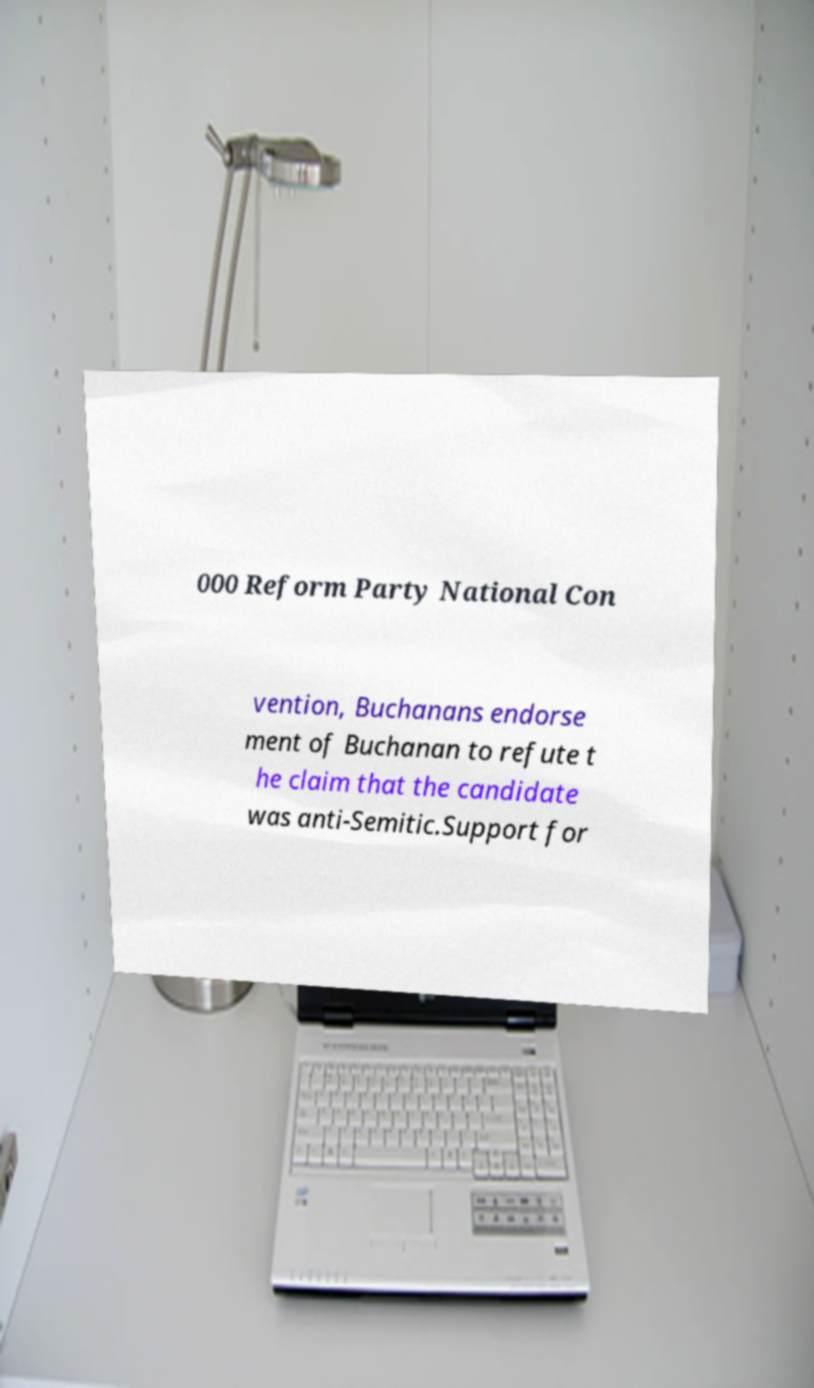Could you assist in decoding the text presented in this image and type it out clearly? 000 Reform Party National Con vention, Buchanans endorse ment of Buchanan to refute t he claim that the candidate was anti-Semitic.Support for 